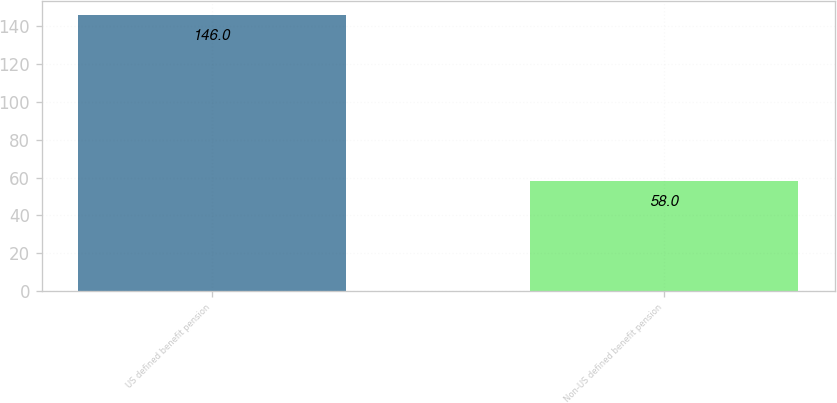Convert chart. <chart><loc_0><loc_0><loc_500><loc_500><bar_chart><fcel>US defined benefit pension<fcel>Non-US defined benefit pension<nl><fcel>146<fcel>58<nl></chart> 